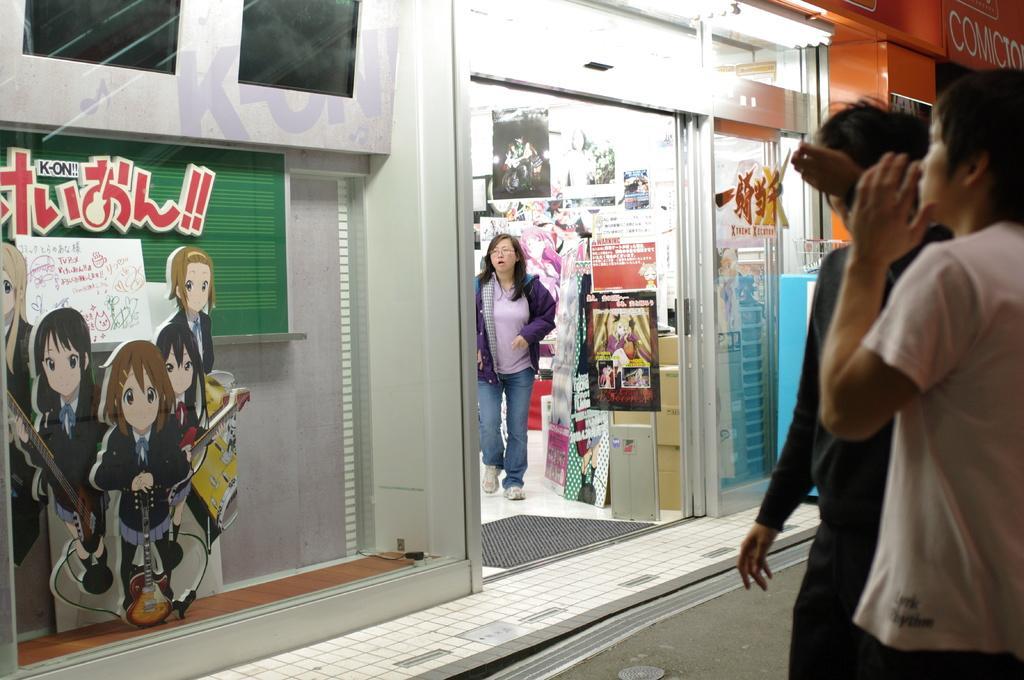In one or two sentences, can you explain what this image depicts? In this image I can see on the left side there are cartoon pictures, images. In the middle a woman is walking from the store, on the right side a man is standing, he wore white color t-shirt and there is another person beside of him. At the top there are lights. 